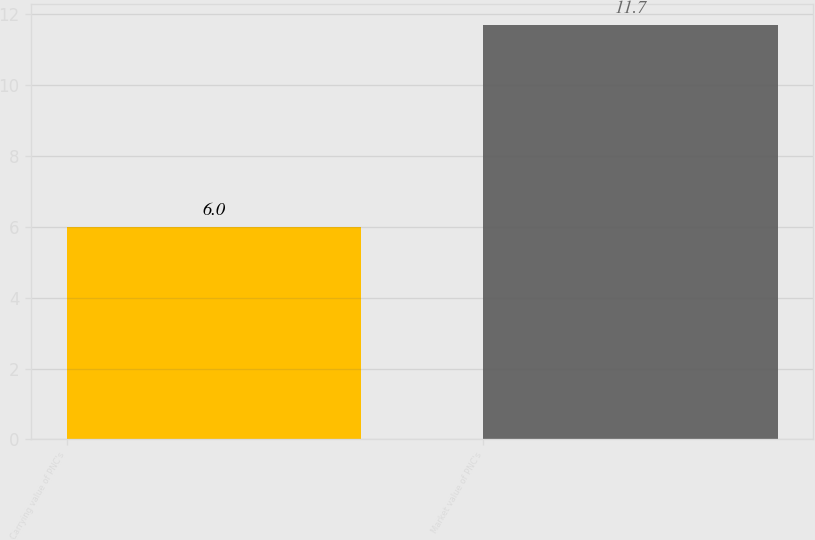Convert chart to OTSL. <chart><loc_0><loc_0><loc_500><loc_500><bar_chart><fcel>Carrying value of PNC's<fcel>Market value of PNC's<nl><fcel>6<fcel>11.7<nl></chart> 